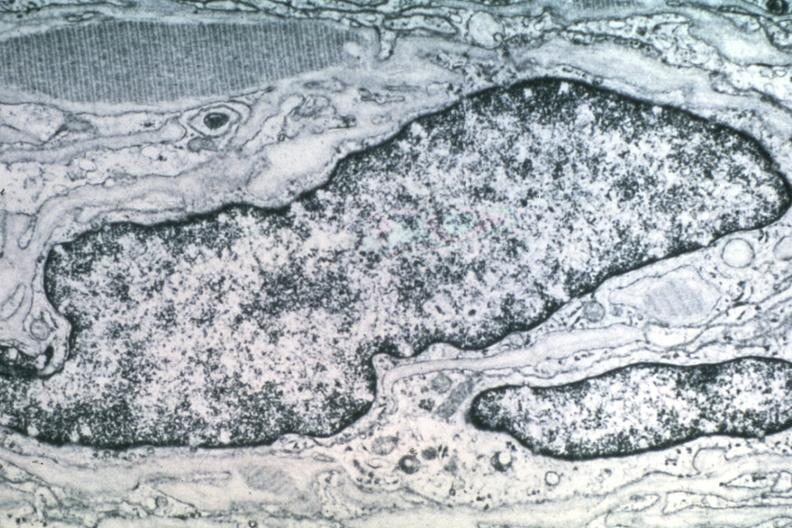what is present?
Answer the question using a single word or phrase. Schwannoma 